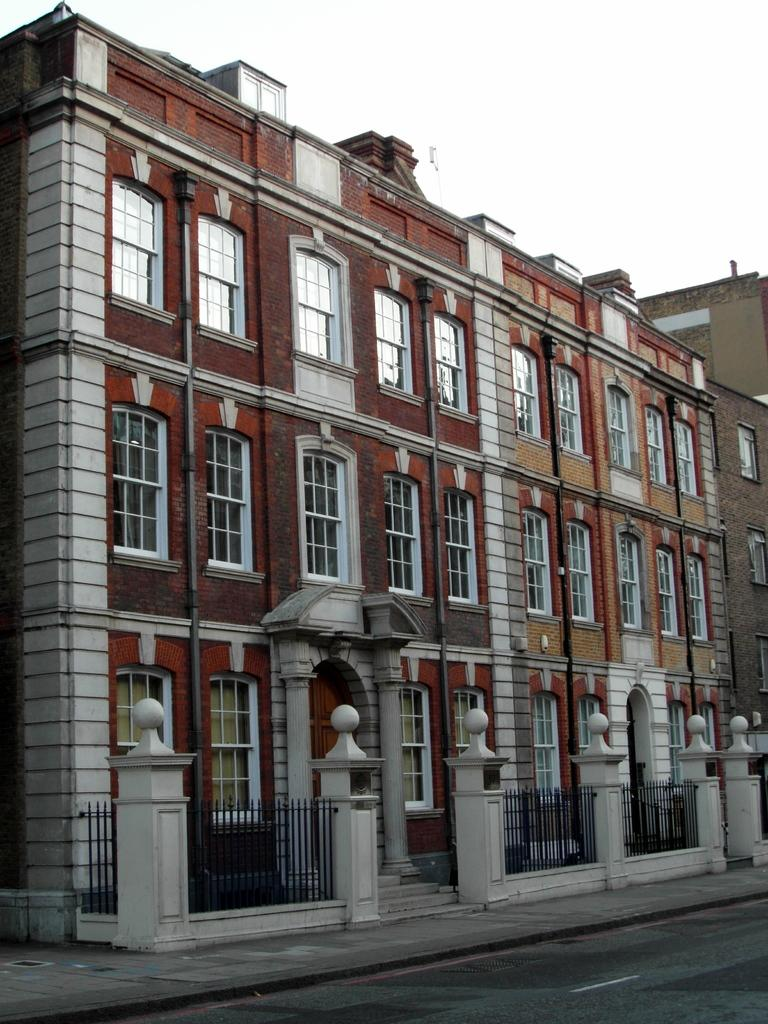What type of structures are present in the image? There are buildings with windows in the image. What architectural feature can be seen on the buildings? There are iron grilles in the image. What can be seen in the background of the image? The sky is visible in the background of the image. Can you tell me how many receipts are scattered on the ground in the image? There are no receipts present in the image. What type of stew is being cooked in the image? There is no stew being cooked in the image. 